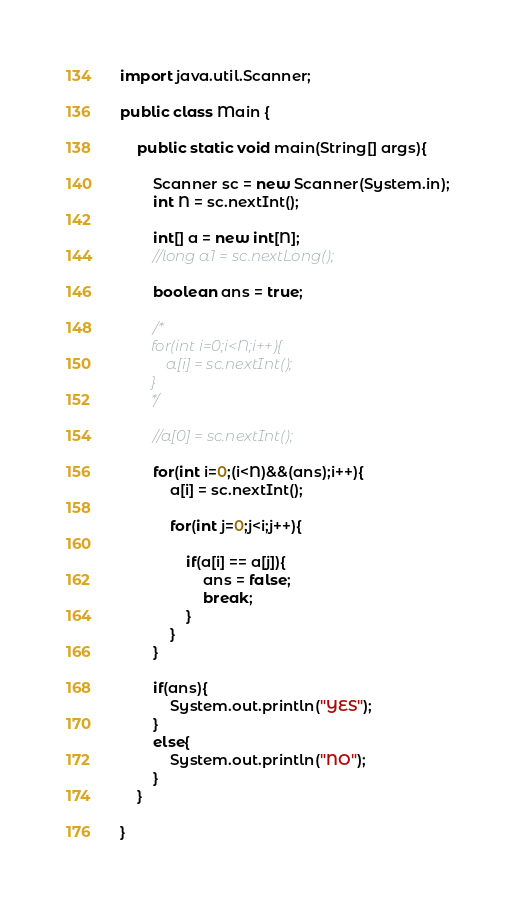<code> <loc_0><loc_0><loc_500><loc_500><_Java_>import java.util.Scanner;

public class Main {
  
	public static void main(String[] args){

		Scanner sc = new Scanner(System.in);
		int N = sc.nextInt();

		int[] a = new int[N];
		//long a1 = sc.nextLong();

		boolean ans = true;

		/*
		for(int i=0;i<N;i++){
			a[i] = sc.nextInt();
		}
		*/

		//a[0] = sc.nextInt();

		for(int i=0;(i<N)&&(ans);i++){
			a[i] = sc.nextInt();
			
			for(int j=0;j<i;j++){

				if(a[i] == a[j]){
					ans = false;
					break;
				}
			}
		}

		if(ans){
			System.out.println("YES");
		}
		else{
			System.out.println("NO");
		}
	}
	
}</code> 